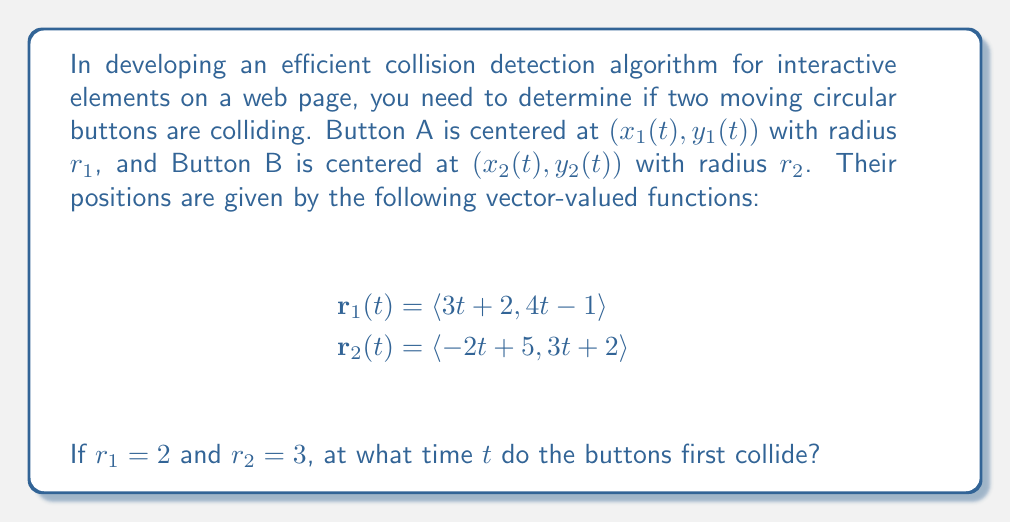Teach me how to tackle this problem. To solve this problem, we need to follow these steps:

1) The buttons collide when the distance between their centers is equal to the sum of their radii. We can express this condition mathematically as:

   $$|\mathbf{r}_1(t) - \mathbf{r}_2(t)| = r_1 + r_2$$

2) Let's calculate $\mathbf{r}_1(t) - \mathbf{r}_2(t)$:
   
   $$\mathbf{r}_1(t) - \mathbf{r}_2(t) = \langle (3t + 2) - (-2t + 5), (4t - 1) - (3t + 2) \rangle$$
   $$= \langle 5t - 3, t - 3 \rangle$$

3) Now, we can set up the equation:

   $$\sqrt{(5t - 3)^2 + (t - 3)^2} = 2 + 3 = 5$$

4) Square both sides:

   $$(5t - 3)^2 + (t - 3)^2 = 25$$

5) Expand:

   $$25t^2 - 30t + 9 + t^2 - 6t + 9 = 25$$

6) Simplify:

   $$26t^2 - 36t - 7 = 0$$

7) This is a quadratic equation. We can solve it using the quadratic formula:

   $$t = \frac{-b \pm \sqrt{b^2 - 4ac}}{2a}$$

   Where $a = 26$, $b = -36$, and $c = -7$

8) Plugging in these values:

   $$t = \frac{36 \pm \sqrt{(-36)^2 - 4(26)(-7)}}{2(26)}$$
   $$= \frac{36 \pm \sqrt{1296 + 728}}{52}$$
   $$= \frac{36 \pm \sqrt{2024}}{52}$$
   $$= \frac{36 \pm 44.99}{52}$$

9) This gives us two solutions:
   
   $$t_1 = \frac{36 + 44.99}{52} \approx 1.56$$
   $$t_2 = \frac{36 - 44.99}{52} \approx -0.17$$

10) Since time cannot be negative in this context, we take the positive solution.
Answer: The buttons first collide at $t \approx 1.56$ seconds. 